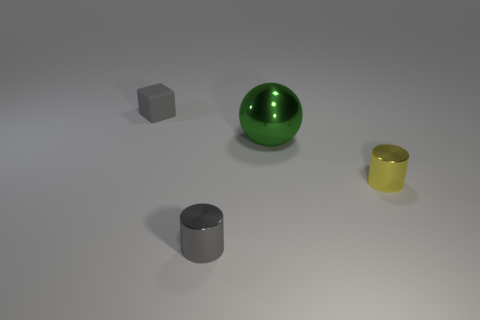Add 1 tiny yellow metallic cylinders. How many objects exist? 5 Subtract all gray cylinders. How many cylinders are left? 1 Subtract all balls. How many objects are left? 3 Subtract 1 blocks. How many blocks are left? 0 Subtract all gray cylinders. Subtract all gray spheres. How many cylinders are left? 1 Subtract all green cubes. How many yellow cylinders are left? 1 Subtract all metal balls. Subtract all tiny rubber things. How many objects are left? 2 Add 4 small gray metal things. How many small gray metal things are left? 5 Add 3 spheres. How many spheres exist? 4 Subtract 0 blue cylinders. How many objects are left? 4 